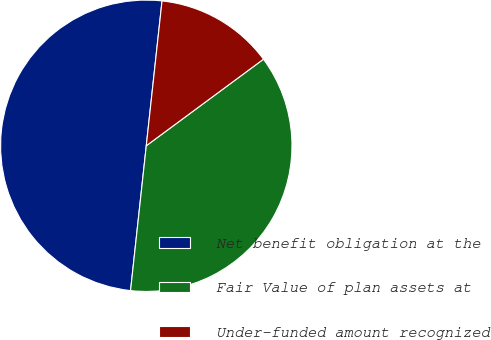Convert chart. <chart><loc_0><loc_0><loc_500><loc_500><pie_chart><fcel>Net benefit obligation at the<fcel>Fair Value of plan assets at<fcel>Under-funded amount recognized<nl><fcel>50.0%<fcel>36.85%<fcel>13.15%<nl></chart> 